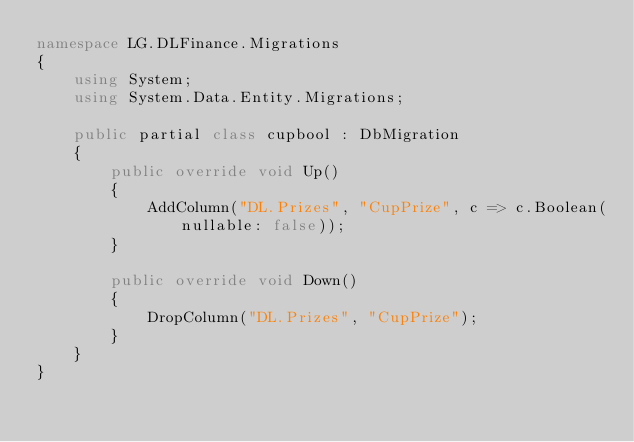Convert code to text. <code><loc_0><loc_0><loc_500><loc_500><_C#_>namespace LG.DLFinance.Migrations
{
    using System;
    using System.Data.Entity.Migrations;
    
    public partial class cupbool : DbMigration
    {
        public override void Up()
        {
            AddColumn("DL.Prizes", "CupPrize", c => c.Boolean(nullable: false));
        }
        
        public override void Down()
        {
            DropColumn("DL.Prizes", "CupPrize");
        }
    }
}
</code> 